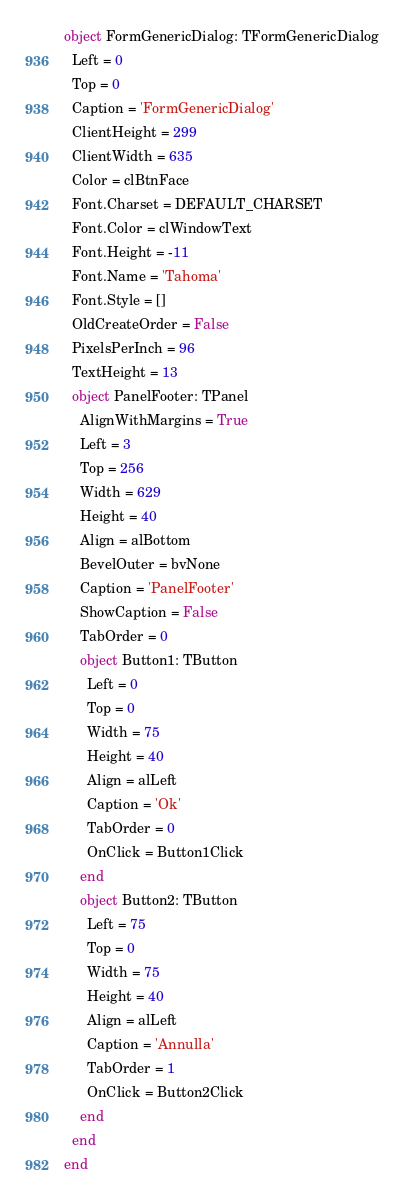<code> <loc_0><loc_0><loc_500><loc_500><_Pascal_>object FormGenericDialog: TFormGenericDialog
  Left = 0
  Top = 0
  Caption = 'FormGenericDialog'
  ClientHeight = 299
  ClientWidth = 635
  Color = clBtnFace
  Font.Charset = DEFAULT_CHARSET
  Font.Color = clWindowText
  Font.Height = -11
  Font.Name = 'Tahoma'
  Font.Style = []
  OldCreateOrder = False
  PixelsPerInch = 96
  TextHeight = 13
  object PanelFooter: TPanel
    AlignWithMargins = True
    Left = 3
    Top = 256
    Width = 629
    Height = 40
    Align = alBottom
    BevelOuter = bvNone
    Caption = 'PanelFooter'
    ShowCaption = False
    TabOrder = 0
    object Button1: TButton
      Left = 0
      Top = 0
      Width = 75
      Height = 40
      Align = alLeft
      Caption = 'Ok'
      TabOrder = 0
      OnClick = Button1Click
    end
    object Button2: TButton
      Left = 75
      Top = 0
      Width = 75
      Height = 40
      Align = alLeft
      Caption = 'Annulla'
      TabOrder = 1
      OnClick = Button2Click
    end
  end
end
</code> 